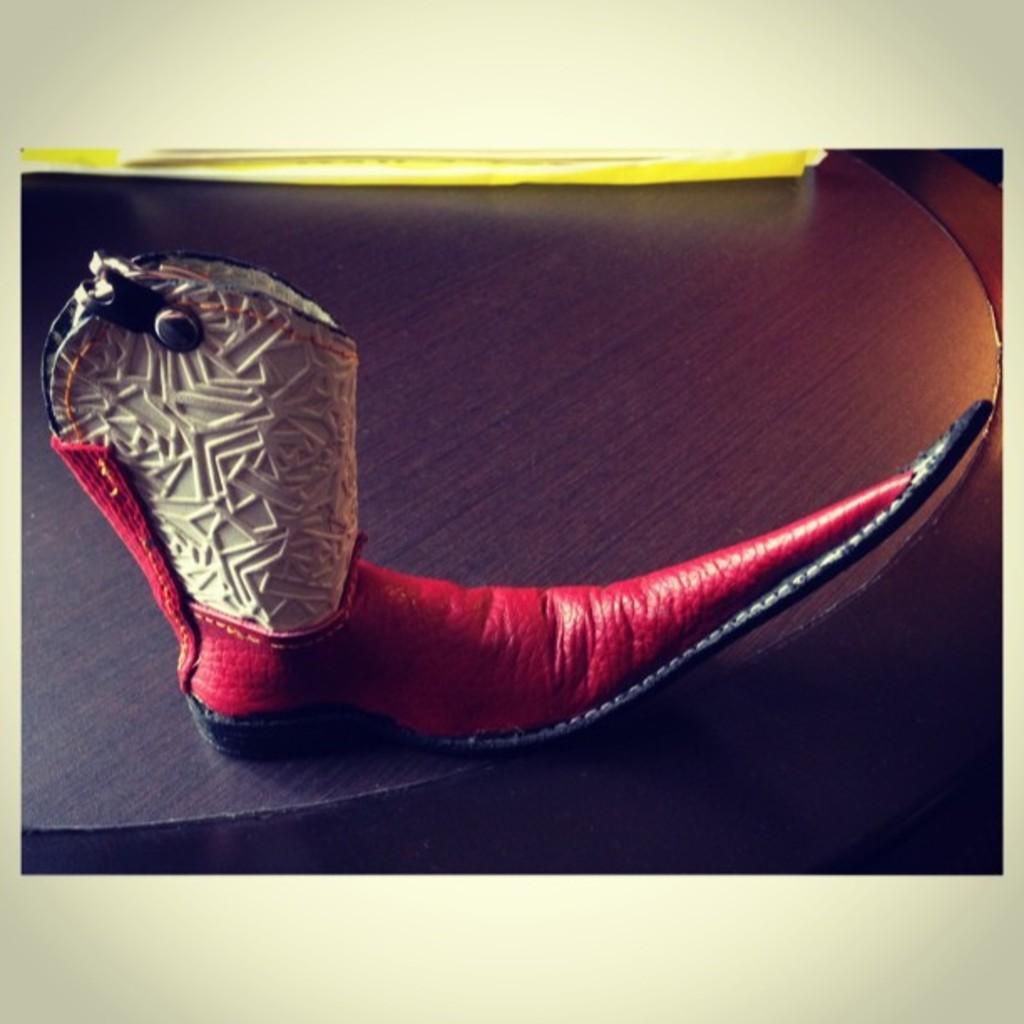In one or two sentences, can you explain what this image depicts? This is a red color shoes. 